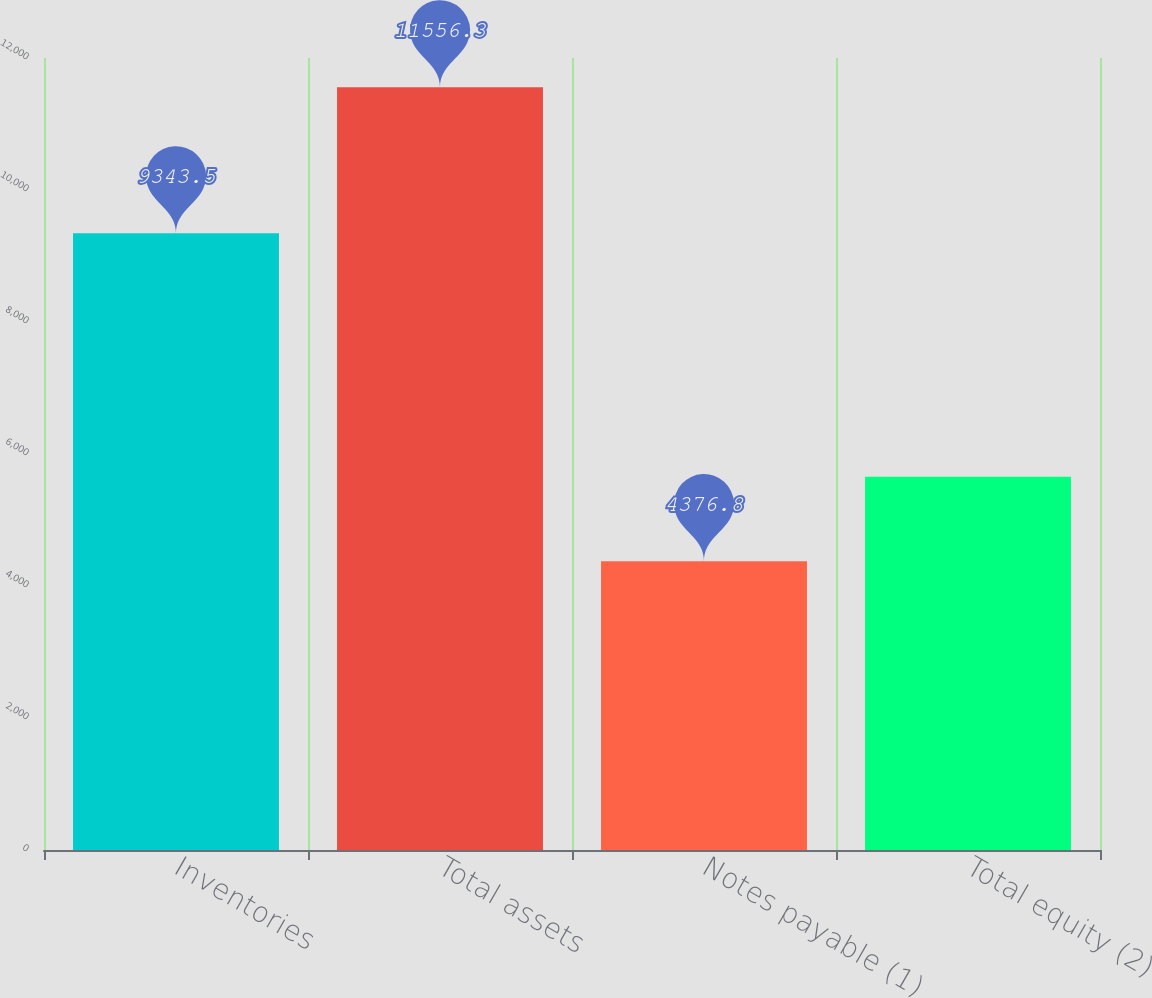Convert chart to OTSL. <chart><loc_0><loc_0><loc_500><loc_500><bar_chart><fcel>Inventories<fcel>Total assets<fcel>Notes payable (1)<fcel>Total equity (2)<nl><fcel>9343.5<fcel>11556.3<fcel>4376.8<fcel>5655.3<nl></chart> 